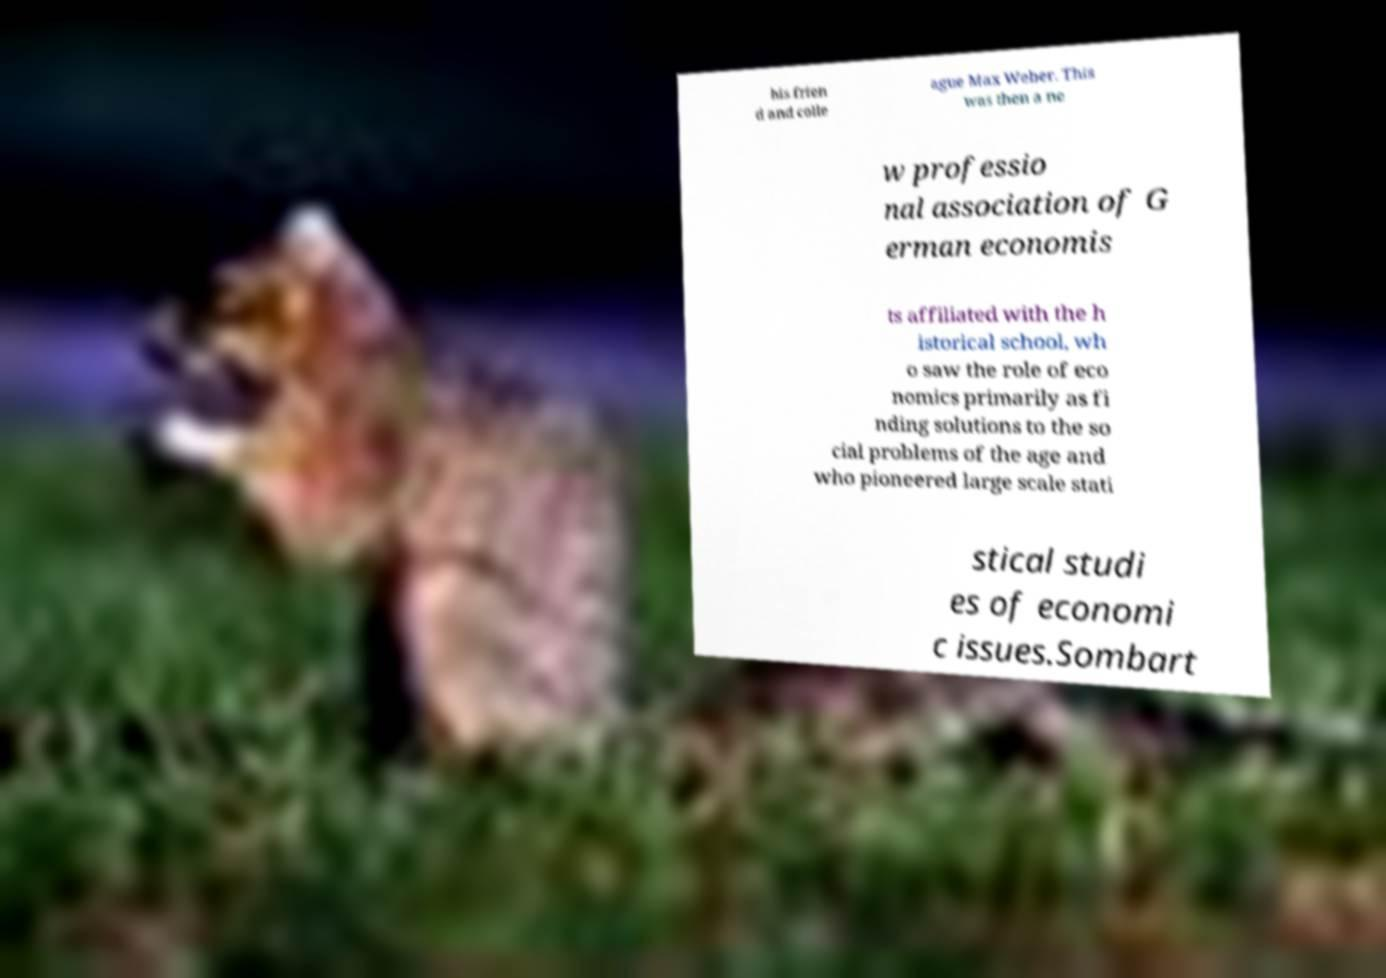Please identify and transcribe the text found in this image. his frien d and colle ague Max Weber. This was then a ne w professio nal association of G erman economis ts affiliated with the h istorical school, wh o saw the role of eco nomics primarily as fi nding solutions to the so cial problems of the age and who pioneered large scale stati stical studi es of economi c issues.Sombart 